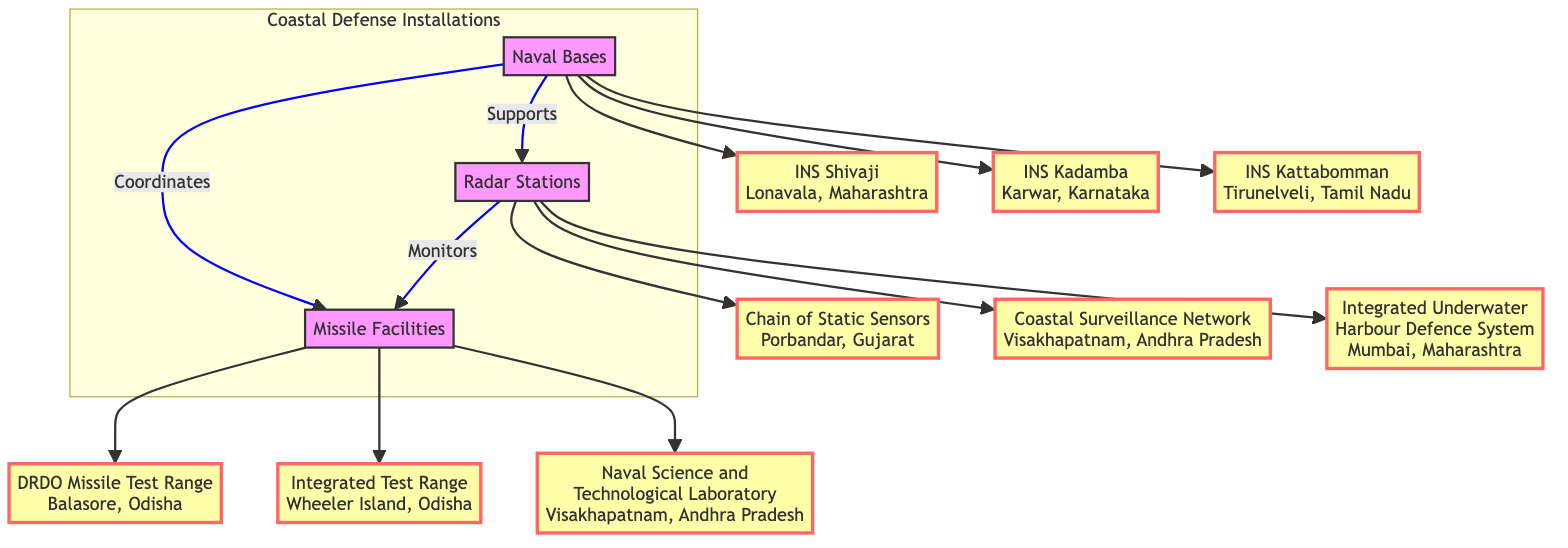What are the names of the naval bases listed in the diagram? According to the diagram, there are three naval bases mentioned: INS Shivaji, INS Kadamba, and INS Kattabomman. Each of these is linked directly to the naval bases node in the diagram.
Answer: INS Shivaji, INS Kadamba, INS Kattabomman Which radar station is associated with Maharashtra? The Integrated Underwater Harbour Defence System is listed as a radar station located in Mumbai, Maharashtra, which connects to the radar stations node.
Answer: Integrated Underwater Harbour Defence System How many missile facilities are shown in the diagram? The diagram displays three missile facilities. They are directly linked to the missile facilities node—DRDO Missile Test Range, Integrated Test Range, and Naval Science and Technological Laboratory.
Answer: 3 What is the relationship between naval bases and missile facilities? The diagram indicates that naval bases coordinate with missile facilities, establishing a direct connection where naval bases influence the operation or location of missile facilities.
Answer: Coordinates Which radar station monitors missile facilities? The diagram shows that radar stations monitor missile facilities, establishing a direct relationship from radar stations to missile facilities.
Answer: Monitors Name the coastal defense installation located in Visakhapatnam, Andhra Pradesh. According to the diagram, there are two installations located in Visakhapatnam: Coastal Surveillance Network (radar station) and Naval Science and Technological Laboratory (missile facility).
Answer: Coastal Surveillance Network, Naval Science and Technological Laboratory How many relationships are shown between different types of installations? The diagram displays three primary relationships connecting the naval bases, radar stations, and missile facilities, illustrating how they interact with one another.
Answer: 3 What province hosts the DRDO Missile Test Range? The diagram specifies that the DRDO Missile Test Range is located in Balasore, Odisha, indicating its geographic setting among the missile facilities.
Answer: Balasore, Odisha 